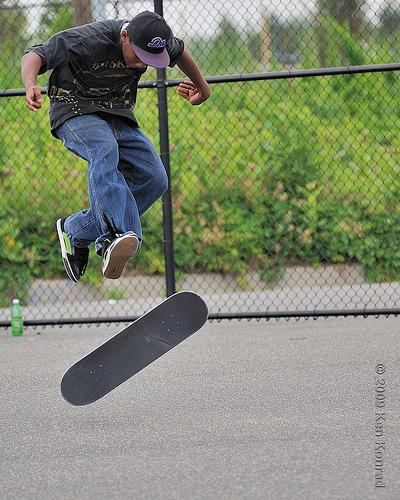Where is the copyright date located in the image, and how would you describe its appearance? The copyright date is located in the lower right corner of the image as a small, printed text. What kind of bottle is in the image and where is it located? There is a green and white soda bottle located on the ground near the bottom-left corner. Count the number of visible screws on the skateboard and provide their location. There are four screws visible on the skateboard, located towards its bottom end. What color and type of clothing are the lower half of the boy covered in? The boy is wearing blue jeans on his lower half. What type of footwear is the boy wearing, and what are the main colors? The boy is wearing black and green skater shoes. Describe the location and appearance of the fence in the image. A large black chain link fence is located on the right side of the image, stretching from top to bottom. What type of area covers a large portion of the top-right corner of the image? A large area covered by growing bushes and trees is in the top-right corner. Identify the type of hat the boy is wearing and describe its colors. The boy is wearing a black and purple baseball hat. What is the main object in the air, and what is its color? The main object in the air is a black skateboard. Describe an object interaction or action taking place in the image. A boy is performing a trick on his skateboard, launching it into the air with him standing on top. How many unique object captions are there for the skater's shoes? Three unique object captions. Describe the skater's outfit including hat, shirt, pants, and shoes. The skater is wearing a black and purple baseball hat, a black short sleeve shirt, blue jeans, and black and green tennis shoes. Is the boy's ear visible in the image? If so, which side? Yes, his right ear is visible. Is there any applique on the boy's clothes and if so, can you describe its colors? Yes, there is a blue and white applique. What is the color of the soda bottle cap? White. Which of these words best describes the skateboard? a) airborne b) grounded c) submerged d) levitating a) airborne What is the main action that the boy is doing in this image? Performing a trick on a skateboard. What is the surface the skateboard is above? Concrete pavement. Where is the copyright information located in the picture? In the corner. Describe the hand of the man in the image. The hand is bent. What kind of fence can be seen in the picture? Large black chain link fence. Is the fence pole in the image short or long? Long. Could you describe the plants found behind the fence? The plants are a section of green bushes. Does the skateboard have screws to hold the wheels on? If so, how many? Yes, there are four screws. Can you identify the object found at the left-top corner of the image? Bottle of soda. Which part of the skateboard is visible in the image? a) Grip tape b) Deck c) Trucks d) Wheels d) Wheels What year can be found in the copyright date on the image? The specific year is not visible. Examine the area outside the fence. What does it consist of? Green grass and growing bushes and trees. What type of shoes is the boy wearing? Tennis shoes. 